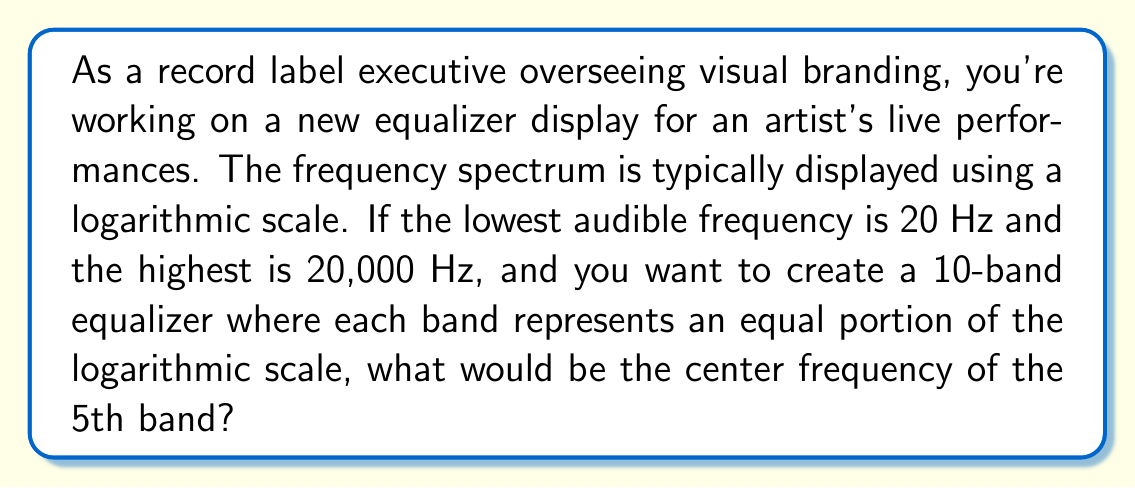What is the answer to this math problem? To solve this problem, we'll use logarithms to create an equal distribution of frequency bands on a logarithmic scale. Here's the step-by-step process:

1) First, we need to calculate the logarithmic range of our frequency spectrum:
   $$\log_{10}(20,000) - \log_{10}(20) = 4 - 1.3010 = 2.6990$$

2) For a 10-band equalizer, we need to divide this range into 10 equal parts:
   $$\frac{2.6990}{10} = 0.2699$$

3) The 5th band will start at 4 full steps above the lowest frequency:
   $$\log_{10}(f_5) = \log_{10}(20) + 4(0.2699) = 1.3010 + 1.0796 = 2.3806$$

4) To find the actual frequency, we need to take the antilog (10 to the power):
   $$f_5 = 10^{2.3806} = 240.0 \text{ Hz}$$

5) This is the lower bound of the 5th band. For the center frequency, we need to go half a step further:
   $$\log_{10}(f_{\text{center}}) = 2.3806 + 0.5(0.2699) = 2.5155$$

6) Taking the antilog again:
   $$f_{\text{center}} = 10^{2.5155} = 327.7 \text{ Hz}$$
Answer: The center frequency of the 5th band is approximately 328 Hz. 